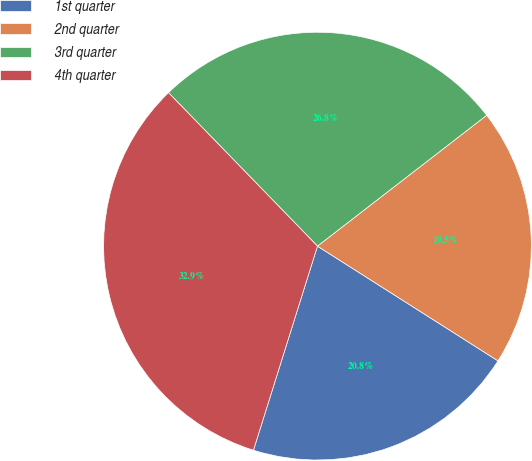Convert chart to OTSL. <chart><loc_0><loc_0><loc_500><loc_500><pie_chart><fcel>1st quarter<fcel>2nd quarter<fcel>3rd quarter<fcel>4th quarter<nl><fcel>20.83%<fcel>19.49%<fcel>26.79%<fcel>32.9%<nl></chart> 